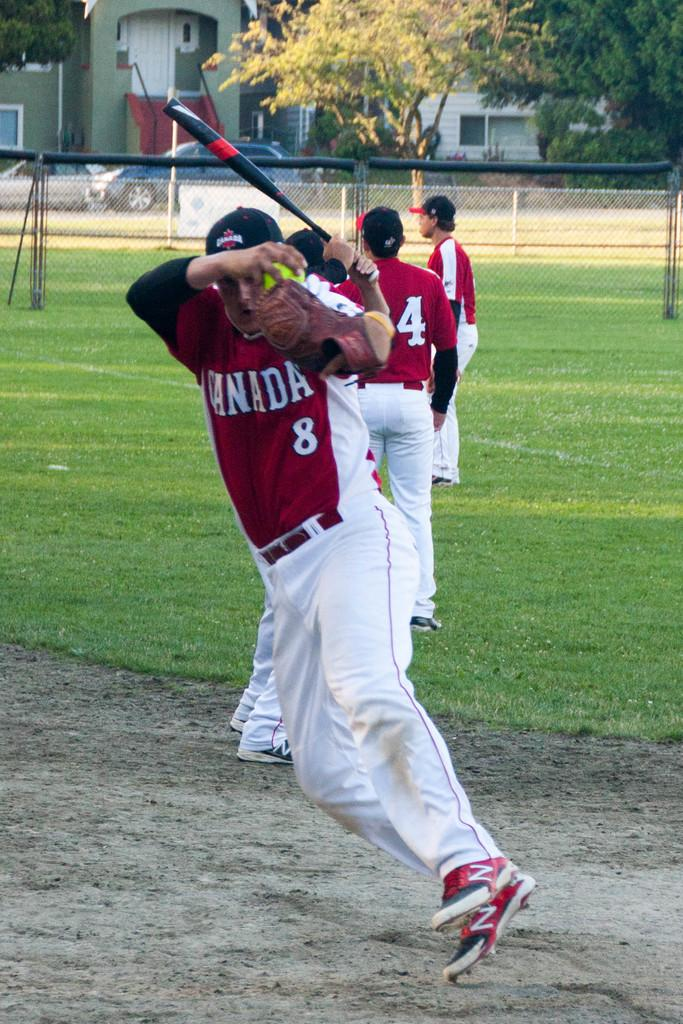Provide a one-sentence caption for the provided image. Baseball players from team Canada practicing on the baseball field. 